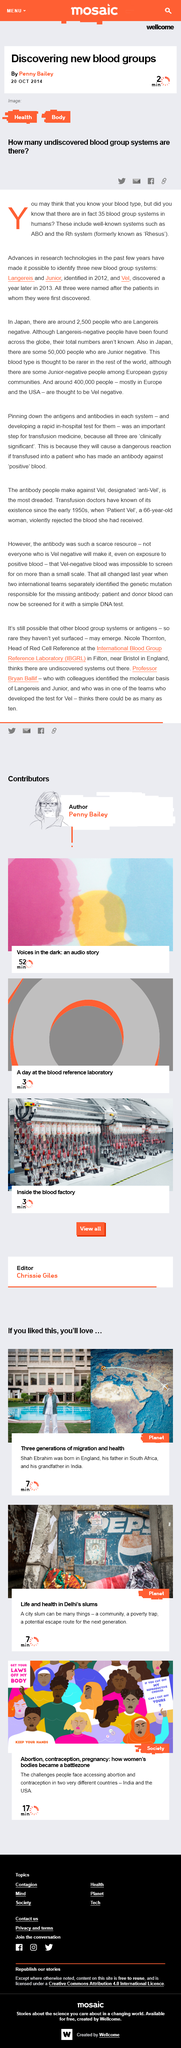Identify some key points in this picture. There are 35 blood group systems in humans, as determined by the existence of various blood group systems in humans. According to estimates, around 400,000 people are believed to be Vel negative. Penny Bailey is the author of the article that reveals the discovery of new blood groups. 